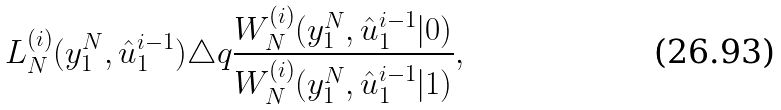Convert formula to latex. <formula><loc_0><loc_0><loc_500><loc_500>L _ { N } ^ { ( i ) } ( y _ { 1 } ^ { N } , \hat { u } _ { 1 } ^ { i - 1 } ) \triangle q \frac { W _ { N } ^ { ( i ) } ( y _ { 1 } ^ { N } , \hat { u } _ { 1 } ^ { i - 1 } | 0 ) } { W _ { N } ^ { ( i ) } ( y _ { 1 } ^ { N } , \hat { u } _ { 1 } ^ { i - 1 } | 1 ) } ,</formula> 